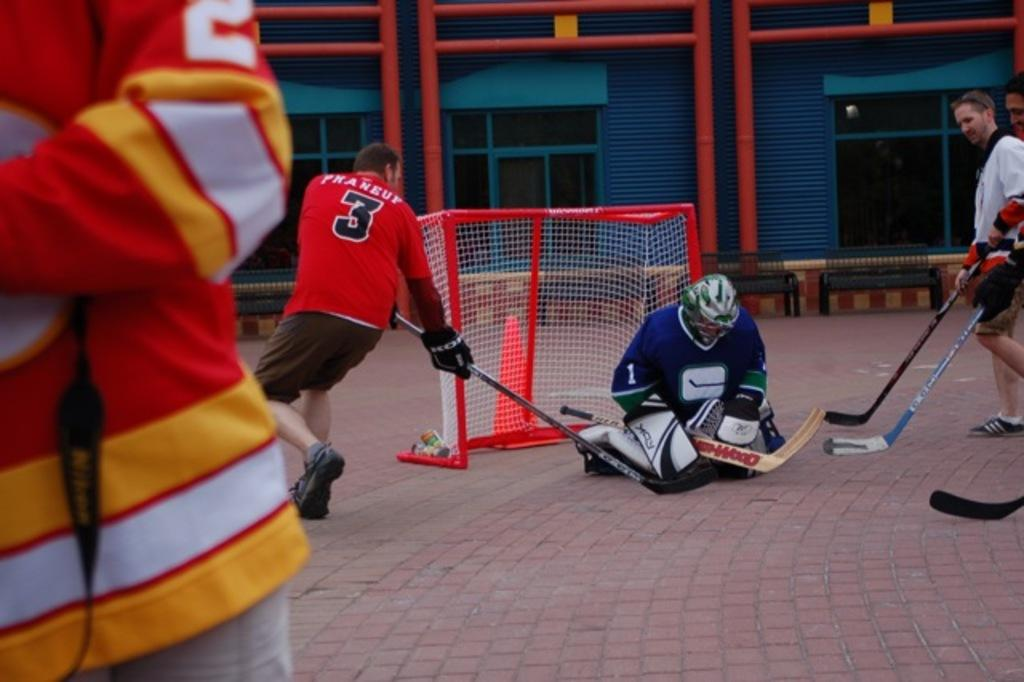<image>
Provide a brief description of the given image. One man in a group of hockey players has a number 3 on his orange colored shirt. 